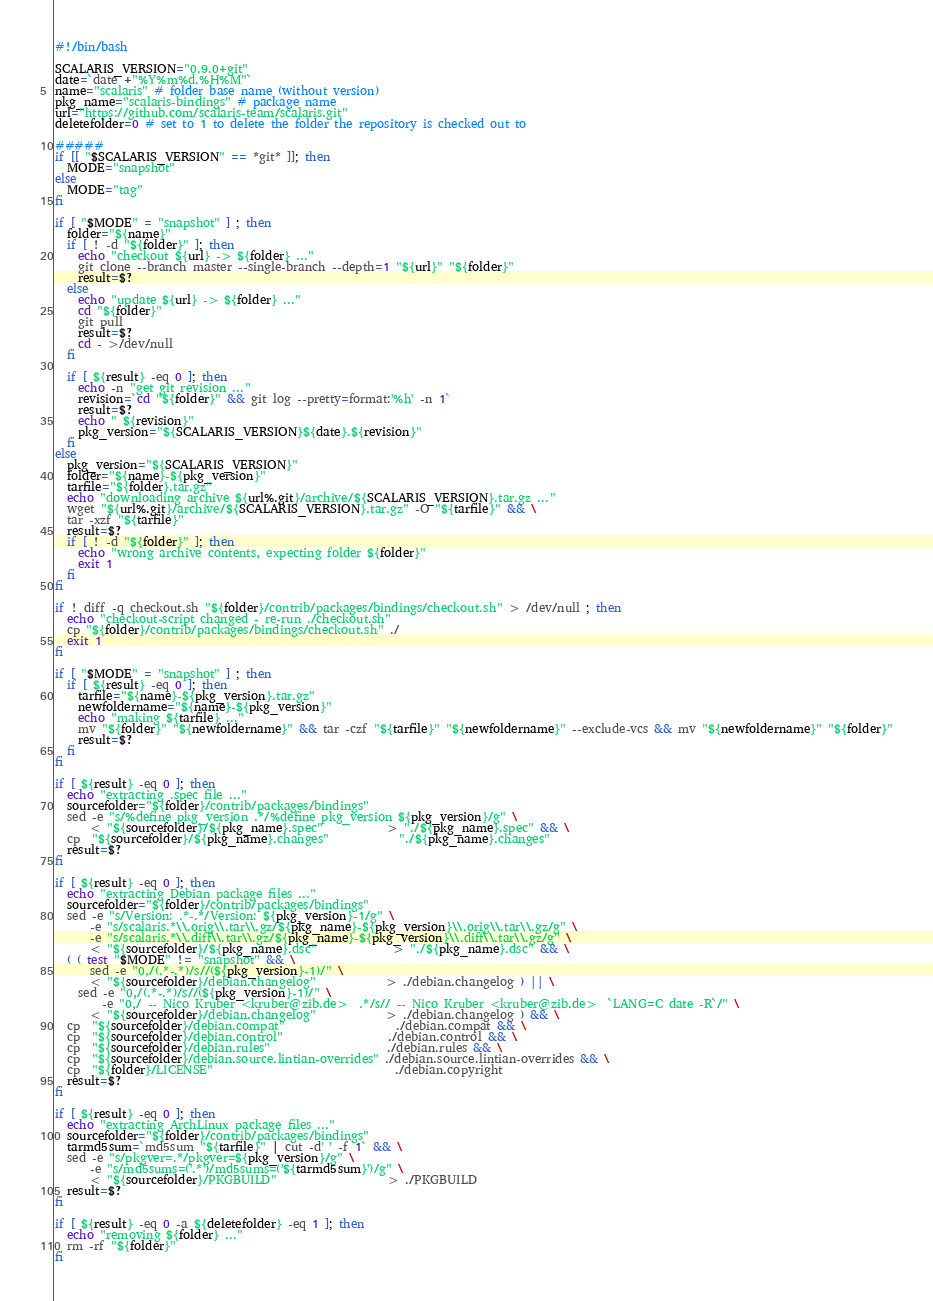Convert code to text. <code><loc_0><loc_0><loc_500><loc_500><_Bash_>#!/bin/bash

SCALARIS_VERSION="0.9.0+git"
date=`date +"%Y%m%d.%H%M"`
name="scalaris" # folder base name (without version)
pkg_name="scalaris-bindings" # package name
url="https://github.com/scalaris-team/scalaris.git"
deletefolder=0 # set to 1 to delete the folder the repository is checked out to

#####
if [[ "$SCALARIS_VERSION" == *git* ]]; then
  MODE="snapshot"
else
  MODE="tag"
fi

if [ "$MODE" = "snapshot" ] ; then
  folder="${name}"
  if [ ! -d "${folder}" ]; then
    echo "checkout ${url} -> ${folder} ..."
    git clone --branch master --single-branch --depth=1 "${url}" "${folder}"
    result=$?
  else
    echo "update ${url} -> ${folder} ..."
    cd "${folder}"
    git pull
    result=$?
    cd - >/dev/null
  fi

  if [ ${result} -eq 0 ]; then
    echo -n "get git revision ..."
    revision=`cd "${folder}" && git log --pretty=format:'%h' -n 1`
    result=$?
    echo " ${revision}"
    pkg_version="${SCALARIS_VERSION}${date}.${revision}"
  fi
else
  pkg_version="${SCALARIS_VERSION}"
  folder="${name}-${pkg_version}"
  tarfile="${folder}.tar.gz"
  echo "downloading archive ${url%.git}/archive/${SCALARIS_VERSION}.tar.gz ..."
  wget "${url%.git}/archive/${SCALARIS_VERSION}.tar.gz" -O "${tarfile}" && \
  tar -xzf "${tarfile}"
  result=$?
  if [ ! -d "${folder}" ]; then
    echo "wrong archive contents, expecting folder ${folder}"
    exit 1
  fi
fi

if ! diff -q checkout.sh "${folder}/contrib/packages/bindings/checkout.sh" > /dev/null ; then
  echo "checkout-script changed - re-run ./checkout.sh"
  cp "${folder}/contrib/packages/bindings/checkout.sh" ./
  exit 1
fi

if [ "$MODE" = "snapshot" ] ; then
  if [ ${result} -eq 0 ]; then
    tarfile="${name}-${pkg_version}.tar.gz"
    newfoldername="${name}-${pkg_version}"
    echo "making ${tarfile} ..."
    mv "${folder}" "${newfoldername}" && tar -czf "${tarfile}" "${newfoldername}" --exclude-vcs && mv "${newfoldername}" "${folder}"
    result=$?
  fi
fi

if [ ${result} -eq 0 ]; then
  echo "extracting .spec file ..."
  sourcefolder="${folder}/contrib/packages/bindings"
  sed -e "s/%define pkg_version .*/%define pkg_version ${pkg_version}/g" \
      < "${sourcefolder}/${pkg_name}.spec"           > "./${pkg_name}.spec" && \
  cp  "${sourcefolder}/${pkg_name}.changes"            "./${pkg_name}.changes"
  result=$?
fi

if [ ${result} -eq 0 ]; then
  echo "extracting Debian package files ..."
  sourcefolder="${folder}/contrib/packages/bindings"
  sed -e "s/Version: .*-.*/Version: ${pkg_version}-1/g" \
      -e "s/scalaris.*\\.orig\\.tar\\.gz/${pkg_name}-${pkg_version}\\.orig\\.tar\\.gz/g" \
      -e "s/scalaris.*\\.diff\\.tar\\.gz/${pkg_name}-${pkg_version}\\.diff\\.tar\\.gz/g" \
      < "${sourcefolder}/${pkg_name}.dsc"             > "./${pkg_name}.dsc" && \
  ( ( test "$MODE" != "snapshot" && \
      sed -e "0,/(.*-.*)/s//(${pkg_version}-1)/" \
      < "${sourcefolder}/debian.changelog"            > ./debian.changelog ) || \
    sed -e "0,/(.*-.*)/s//(${pkg_version}-1)/" \
        -e "0,/ -- Nico Kruber <kruber@zib.de>  .*/s// -- Nico Kruber <kruber@zib.de>  `LANG=C date -R`/" \
      < "${sourcefolder}/debian.changelog"            > ./debian.changelog ) && \
  cp  "${sourcefolder}/debian.compat"                   ./debian.compat && \
  cp  "${sourcefolder}/debian.control"                  ./debian.control && \
  cp  "${sourcefolder}/debian.rules"                    ./debian.rules && \
  cp  "${sourcefolder}/debian.source.lintian-overrides" ./debian.source.lintian-overrides && \
  cp  "${folder}/LICENSE"                               ./debian.copyright
  result=$?
fi

if [ ${result} -eq 0 ]; then
  echo "extracting ArchLinux package files ..."
  sourcefolder="${folder}/contrib/packages/bindings"
  tarmd5sum=`md5sum "${tarfile}" | cut -d' ' -f 1` && \
  sed -e "s/pkgver=.*/pkgver=${pkg_version}/g" \
      -e "s/md5sums=('.*')/md5sums=('${tarmd5sum}')/g" \
      < "${sourcefolder}/PKGBUILD"                   > ./PKGBUILD
  result=$?
fi

if [ ${result} -eq 0 -a ${deletefolder} -eq 1 ]; then
  echo "removing ${folder} ..."
  rm -rf "${folder}"
fi
</code> 